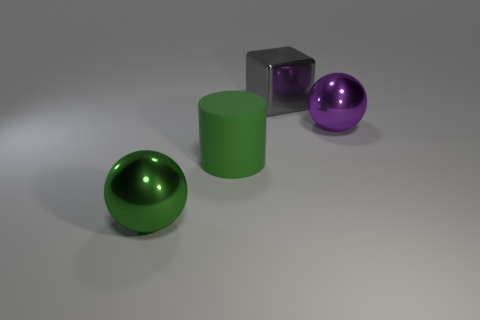Add 4 matte cylinders. How many objects exist? 8 Subtract all blocks. How many objects are left? 3 Subtract all small purple cylinders. Subtract all shiny objects. How many objects are left? 1 Add 3 big gray things. How many big gray things are left? 4 Add 1 large purple balls. How many large purple balls exist? 2 Subtract 0 red cubes. How many objects are left? 4 